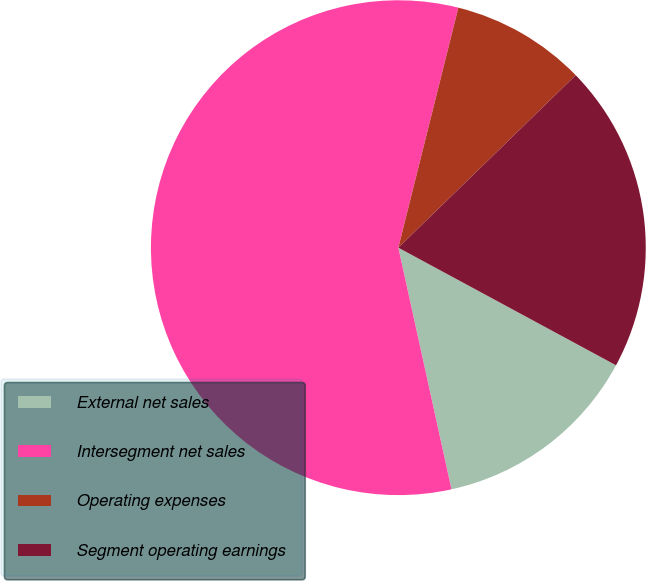<chart> <loc_0><loc_0><loc_500><loc_500><pie_chart><fcel>External net sales<fcel>Intersegment net sales<fcel>Operating expenses<fcel>Segment operating earnings<nl><fcel>13.67%<fcel>57.34%<fcel>8.82%<fcel>20.16%<nl></chart> 